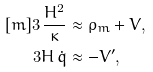<formula> <loc_0><loc_0><loc_500><loc_500>[ m ] 3 \, \frac { H ^ { 2 } } { \kappa } & \approx \rho _ { m } + V , \\ 3 H \, \dot { q } & \approx - V ^ { \prime } ,</formula> 